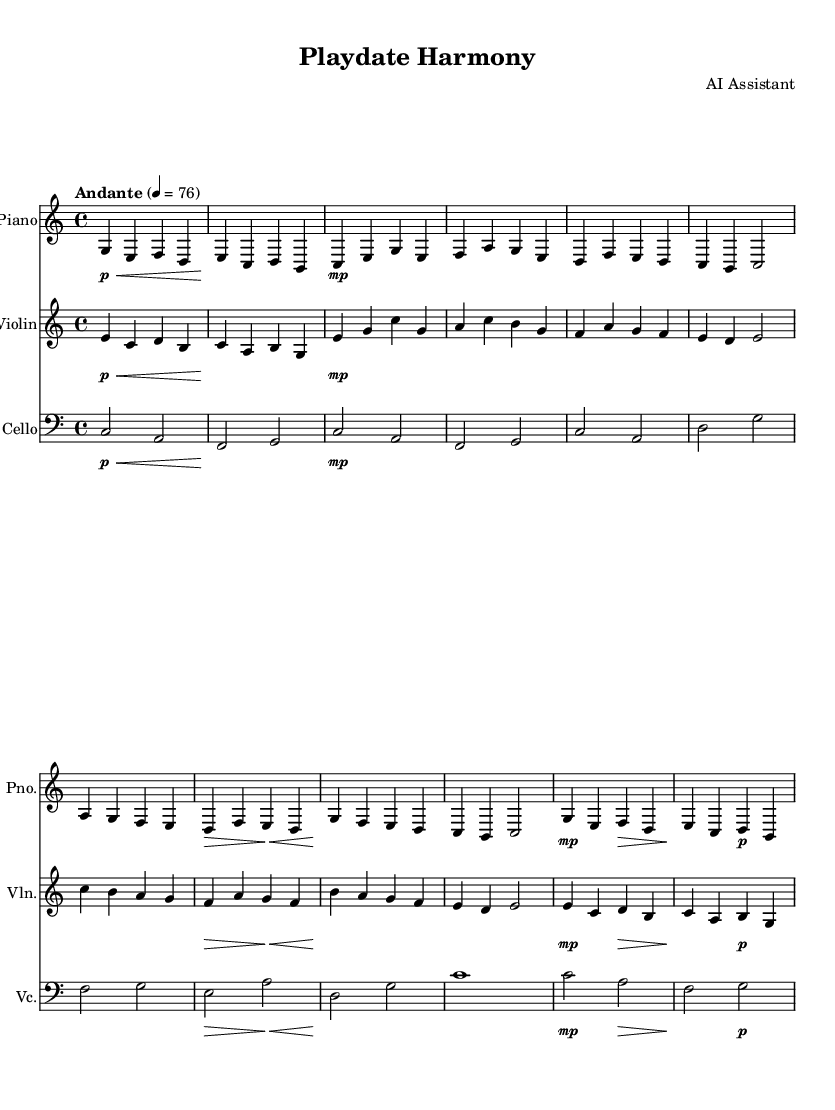What is the key signature of this music? The key signature is C major, which has no sharps or flats.
Answer: C major What is the time signature of this piece? The time signature is located at the beginning of the score and indicates that there are four beats in each measure.
Answer: 4/4 What is the tempo marking for this music? The tempo marking is found at the beginning and indicates a moderate speed, which is Andante at a quarter note equals 76 beats per minute.
Answer: Andante How many measures are in the piano part? By counting the distinct groupings of notes separated by vertical lines, there are thirteen measures in the piano part.
Answer: Thirteen Which instruments are featured in this score? The score includes three instruments, and their names can be found at the start of each staff. The instruments are piano, violin, and cello.
Answer: Piano, violin, cello What dynamics are indicated for the violin in the first measure? The first measure for the violin indicates a piano dynamic level, seen by the marking at the start of the staff.
Answer: Piano Explain the overall character of the piece based on its dynamics and tempo. The piece maintains a gentle and calm atmosphere throughout due to its consistent use of soft dynamics and moderate tempo, making it suitable for background music in social interactions.
Answer: Gentle and calm 